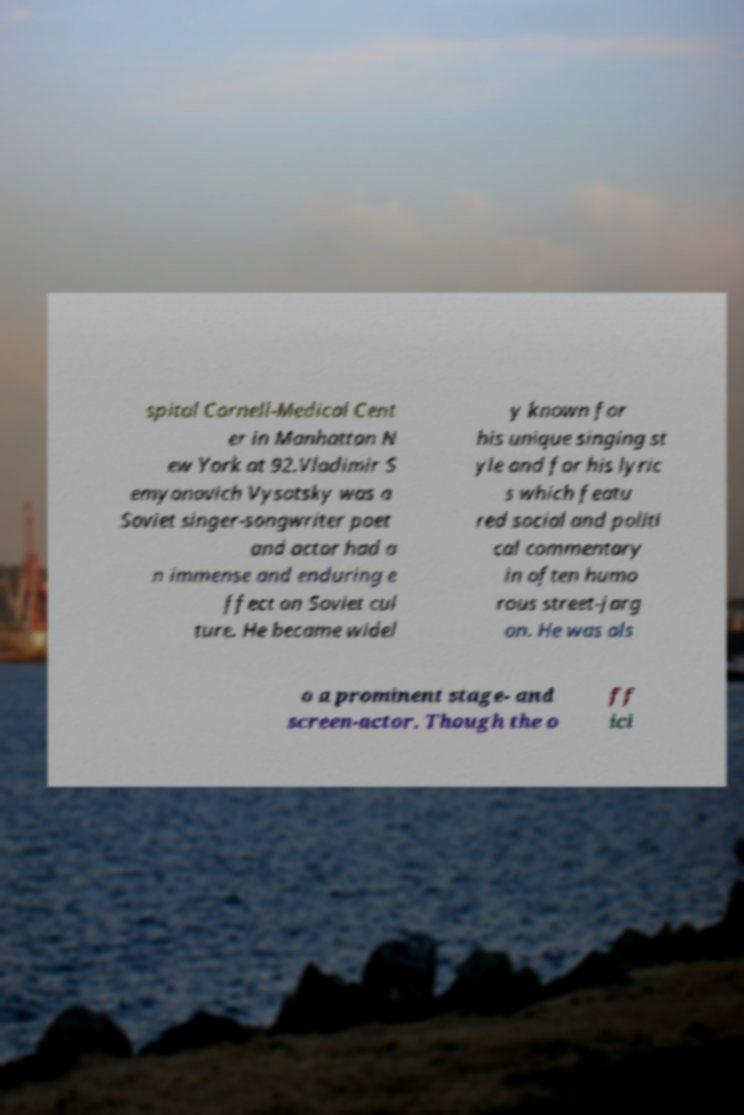Could you assist in decoding the text presented in this image and type it out clearly? spital Cornell-Medical Cent er in Manhattan N ew York at 92.Vladimir S emyonovich Vysotsky was a Soviet singer-songwriter poet and actor had a n immense and enduring e ffect on Soviet cul ture. He became widel y known for his unique singing st yle and for his lyric s which featu red social and politi cal commentary in often humo rous street-jarg on. He was als o a prominent stage- and screen-actor. Though the o ff ici 